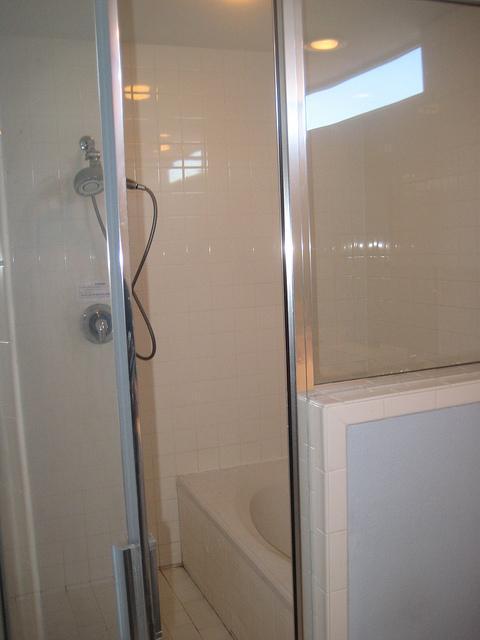How many toilets are there?
Give a very brief answer. 1. 